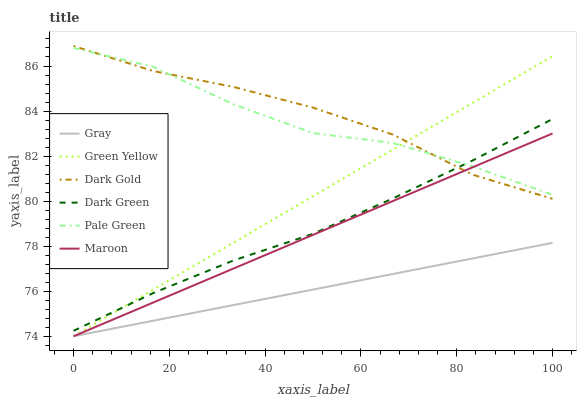Does Gray have the minimum area under the curve?
Answer yes or no. Yes. Does Dark Gold have the maximum area under the curve?
Answer yes or no. Yes. Does Maroon have the minimum area under the curve?
Answer yes or no. No. Does Maroon have the maximum area under the curve?
Answer yes or no. No. Is Gray the smoothest?
Answer yes or no. Yes. Is Pale Green the roughest?
Answer yes or no. Yes. Is Dark Gold the smoothest?
Answer yes or no. No. Is Dark Gold the roughest?
Answer yes or no. No. Does Gray have the lowest value?
Answer yes or no. Yes. Does Dark Gold have the lowest value?
Answer yes or no. No. Does Dark Gold have the highest value?
Answer yes or no. Yes. Does Maroon have the highest value?
Answer yes or no. No. Is Gray less than Pale Green?
Answer yes or no. Yes. Is Dark Gold greater than Gray?
Answer yes or no. Yes. Does Maroon intersect Dark Gold?
Answer yes or no. Yes. Is Maroon less than Dark Gold?
Answer yes or no. No. Is Maroon greater than Dark Gold?
Answer yes or no. No. Does Gray intersect Pale Green?
Answer yes or no. No. 